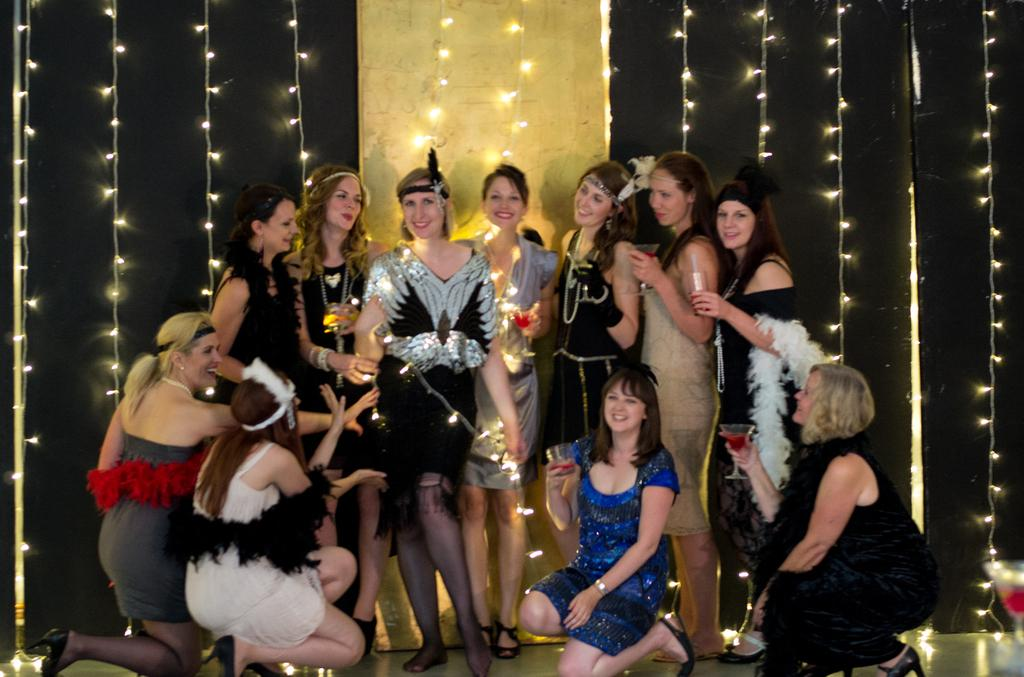What is the main subject of the image? The main subject of the image is a group of girls. Where are the girls located in the image? The girls are sitting and standing on a stage. What are some of the girls holding in the image? Some of the girls are holding glasses. What can be seen behind the stage in the image? There is a wall behind the stage, and it has lights on it. How many apples are being used to support the stage in the image? There are no apples present in the image, and they are not being used to support the stage. 